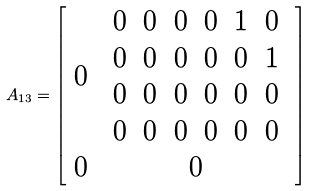Convert formula to latex. <formula><loc_0><loc_0><loc_500><loc_500>A _ { 1 3 } = \left [ \begin{array} { c c } 0 & \begin{array} { c c c c c c } 0 & 0 & 0 & 0 & 1 & 0 \\ 0 & 0 & 0 & 0 & 0 & 1 \\ 0 & 0 & 0 & 0 & 0 & 0 \\ 0 & 0 & 0 & 0 & 0 & 0 \end{array} \\ 0 & 0 \end{array} \right ]</formula> 